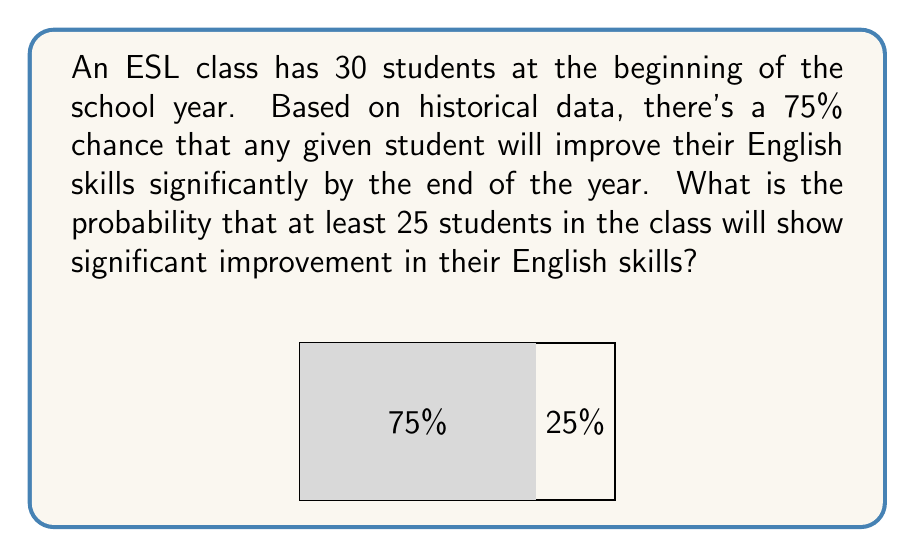Provide a solution to this math problem. Let's approach this step-by-step:

1) This is a binomial probability problem. We need to find $P(X \geq 25)$ where $X$ is the number of students who improve significantly.

2) The parameters for our binomial distribution are:
   $n = 30$ (number of students)
   $p = 0.75$ (probability of success for each student)

3) We can calculate this using the cumulative binomial probability formula:

   $P(X \geq 25) = 1 - P(X < 25) = 1 - P(X \leq 24)$

4) Using the binomial probability formula:

   $P(X = k) = \binom{n}{k} p^k (1-p)^{n-k}$

5) We need to sum this for $k = 0$ to $24$:

   $P(X \leq 24) = \sum_{k=0}^{24} \binom{30}{k} (0.75)^k (0.25)^{30-k}$

6) This sum is complex to calculate by hand, so we would typically use statistical software or a calculator with binomial probability functions.

7) Using such a tool, we find:

   $P(X \leq 24) \approx 0.1318$

8) Therefore:

   $P(X \geq 25) = 1 - P(X \leq 24) \approx 1 - 0.1318 = 0.8682$

So, the probability that at least 25 students will show significant improvement is approximately 0.8682 or 86.82%.
Answer: $0.8682$ or $86.82\%$ 